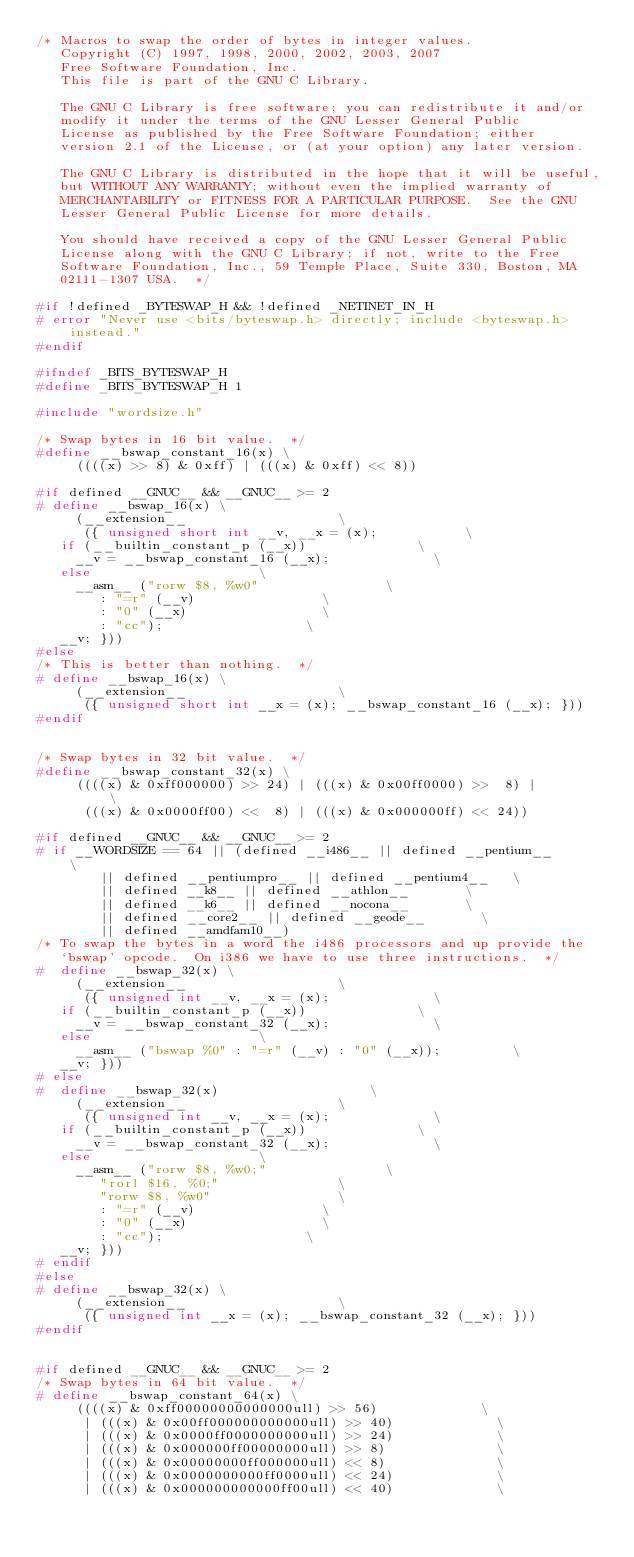<code> <loc_0><loc_0><loc_500><loc_500><_C_>/* Macros to swap the order of bytes in integer values.
   Copyright (C) 1997, 1998, 2000, 2002, 2003, 2007
   Free Software Foundation, Inc.
   This file is part of the GNU C Library.

   The GNU C Library is free software; you can redistribute it and/or
   modify it under the terms of the GNU Lesser General Public
   License as published by the Free Software Foundation; either
   version 2.1 of the License, or (at your option) any later version.

   The GNU C Library is distributed in the hope that it will be useful,
   but WITHOUT ANY WARRANTY; without even the implied warranty of
   MERCHANTABILITY or FITNESS FOR A PARTICULAR PURPOSE.  See the GNU
   Lesser General Public License for more details.

   You should have received a copy of the GNU Lesser General Public
   License along with the GNU C Library; if not, write to the Free
   Software Foundation, Inc., 59 Temple Place, Suite 330, Boston, MA
   02111-1307 USA.  */

#if !defined _BYTESWAP_H && !defined _NETINET_IN_H
# error "Never use <bits/byteswap.h> directly; include <byteswap.h> instead."
#endif

#ifndef _BITS_BYTESWAP_H
#define _BITS_BYTESWAP_H 1

#include "wordsize.h"

/* Swap bytes in 16 bit value.  */
#define __bswap_constant_16(x) \
     ((((x) >> 8) & 0xff) | (((x) & 0xff) << 8))

#if defined __GNUC__ && __GNUC__ >= 2
# define __bswap_16(x) \
     (__extension__							      \
      ({ unsigned short int __v, __x = (x);			      \
	 if (__builtin_constant_p (__x))				      \
	   __v = __bswap_constant_16 (__x);				      \
	 else								      \
	   __asm__ ("rorw $8, %w0"					      \
		    : "=r" (__v)					      \
		    : "0" (__x)						      \
		    : "cc");						      \
	 __v; }))
#else
/* This is better than nothing.  */
# define __bswap_16(x) \
     (__extension__							      \
      ({ unsigned short int __x = (x); __bswap_constant_16 (__x); }))
#endif


/* Swap bytes in 32 bit value.  */
#define __bswap_constant_32(x) \
     ((((x) & 0xff000000) >> 24) | (((x) & 0x00ff0000) >>  8) |		      \
      (((x) & 0x0000ff00) <<  8) | (((x) & 0x000000ff) << 24))

#if defined __GNUC__ && __GNUC__ >= 2
# if __WORDSIZE == 64 || (defined __i486__ || defined __pentium__	      \
			  || defined __pentiumpro__ || defined __pentium4__   \
			  || defined __k8__ || defined __athlon__	      \
			  || defined __k6__ || defined __nocona__	      \
			  || defined __core2__ || defined __geode__	      \
			  || defined __amdfam10__)
/* To swap the bytes in a word the i486 processors and up provide the
   `bswap' opcode.  On i386 we have to use three instructions.  */
#  define __bswap_32(x) \
     (__extension__							      \
      ({ unsigned int __v, __x = (x);				      \
	 if (__builtin_constant_p (__x))				      \
	   __v = __bswap_constant_32 (__x);				      \
	 else								      \
	   __asm__ ("bswap %0" : "=r" (__v) : "0" (__x));		      \
	 __v; }))
# else
#  define __bswap_32(x)							      \
     (__extension__							      \
      ({ unsigned int __v, __x = (x);				      \
	 if (__builtin_constant_p (__x))				      \
	   __v = __bswap_constant_32 (__x);				      \
	 else								      \
	   __asm__ ("rorw $8, %w0;"					      \
		    "rorl $16, %0;"					      \
		    "rorw $8, %w0"					      \
		    : "=r" (__v)					      \
		    : "0" (__x)						      \
		    : "cc");						      \
	 __v; }))
# endif
#else
# define __bswap_32(x) \
     (__extension__							      \
      ({ unsigned int __x = (x); __bswap_constant_32 (__x); }))
#endif


#if defined __GNUC__ && __GNUC__ >= 2
/* Swap bytes in 64 bit value.  */
# define __bswap_constant_64(x) \
     ((((x) & 0xff00000000000000ull) >> 56)				      \
      | (((x) & 0x00ff000000000000ull) >> 40)				      \
      | (((x) & 0x0000ff0000000000ull) >> 24)				      \
      | (((x) & 0x000000ff00000000ull) >> 8)				      \
      | (((x) & 0x00000000ff000000ull) << 8)				      \
      | (((x) & 0x0000000000ff0000ull) << 24)				      \
      | (((x) & 0x000000000000ff00ull) << 40)				      \</code> 